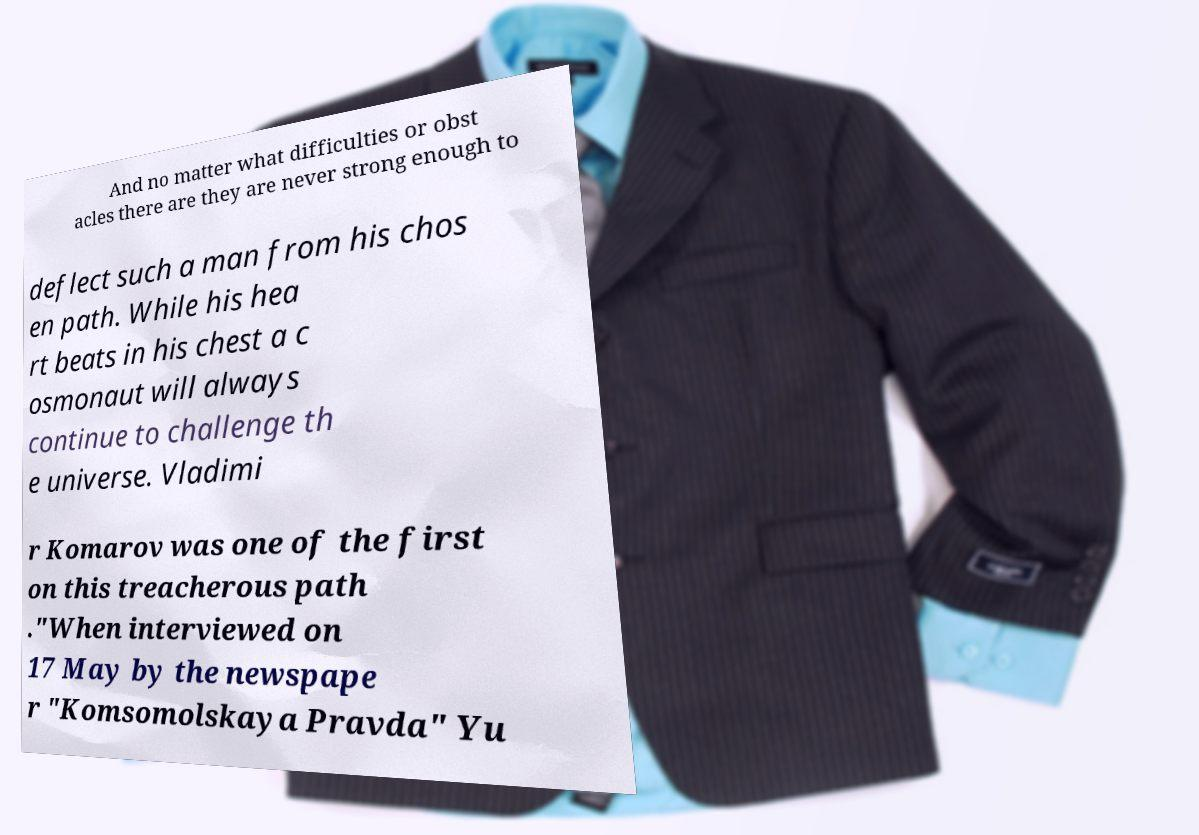Could you assist in decoding the text presented in this image and type it out clearly? And no matter what difficulties or obst acles there are they are never strong enough to deflect such a man from his chos en path. While his hea rt beats in his chest a c osmonaut will always continue to challenge th e universe. Vladimi r Komarov was one of the first on this treacherous path ."When interviewed on 17 May by the newspape r "Komsomolskaya Pravda" Yu 